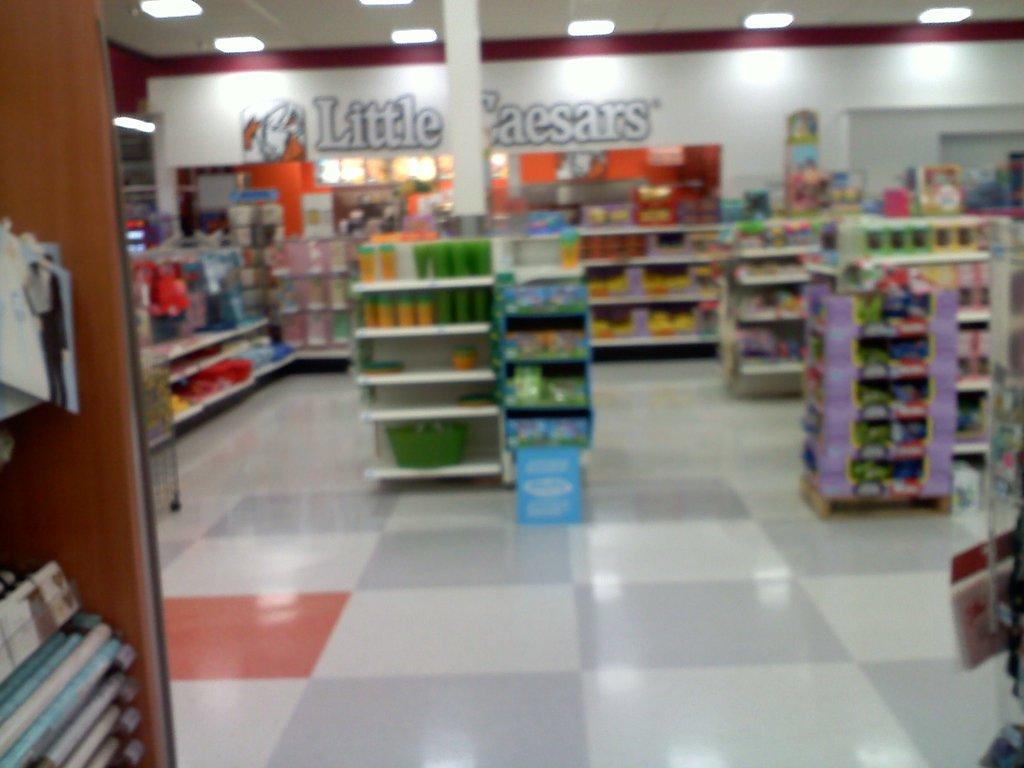What restaurant is at the back of the store?
Provide a short and direct response. Little caesars. 